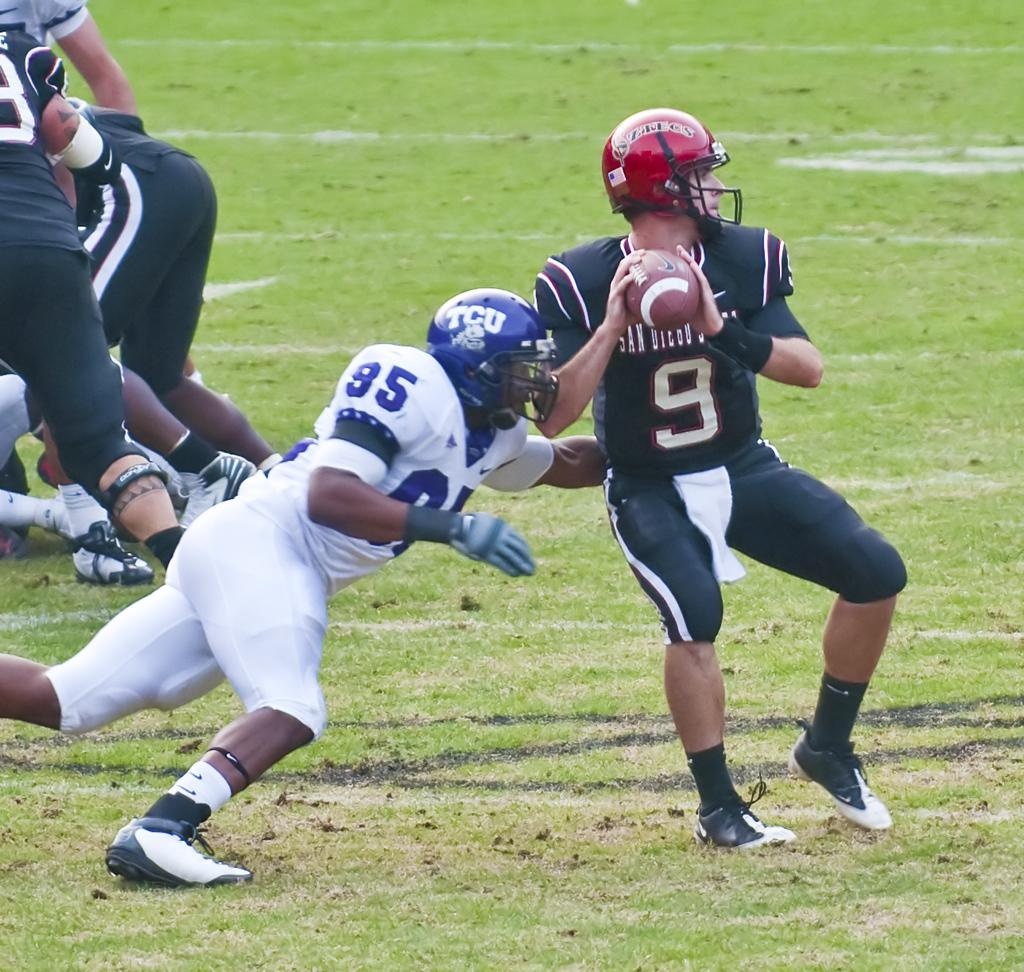How many people are in the image? There are persons in the image. What is the position of the persons in the image? The persons are on the ground. What object is one of the persons holding in their hands? One of the persons is holding a ball in their hands. What type of boot is the person wearing on their left foot in the image? There is no information about footwear in the image, so it cannot be determined if any person is wearing a boot or what type it might be. 